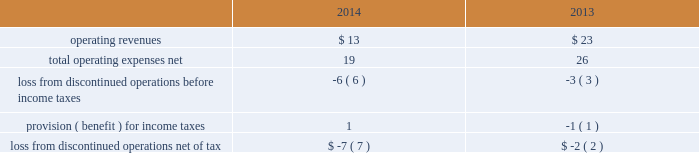During 2014 , the company closed on thirteen acquisitions of various regulated water and wastewater systems for a total aggregate purchase price of $ 9 .
Assets acquired , principally plant , totaled $ 17 .
Liabilities assumed totaled $ 8 , including $ 5 of contributions in aid of construction and assumed debt of $ 2 .
During 2013 , the company closed on fifteen acquisitions of various regulated water and wastewater systems for a total aggregate net purchase price of $ 24 .
Assets acquired , primarily utility plant , totaled $ 67 .
Liabilities assumed totaled $ 43 , including $ 26 of contributions in aid of construction and assumed debt of $ 13 .
Included in these totals was the company 2019s november 14 , 2013 acquisition of all of the capital stock of dale service corporation ( 201cdale 201d ) , a regulated wastewater utility company , for a total cash purchase price of $ 5 ( net of cash acquired of $ 7 ) , plus assumed liabilities .
The dale acquisition was accounted for as a business combination ; accordingly , operating results from november 14 , 2013 were included in the company 2019s results of operations .
The purchase price was allocated to the net tangible and intangible assets based upon their estimated fair values at the date of acquisition .
The company 2019s regulatory practice was followed whereby property , plant and equipment ( rate base ) was considered fair value for business combination purposes .
Similarly , regulatory assets and liabilities acquired were recorded at book value and are subject to regulatory approval where applicable .
The acquired debt was valued in a manner consistent with the company 2019s level 3 debt .
See note 17 2014fair value of financial instruments .
Non-cash assets acquired in the dale acquisition , primarily utility plant , totaled $ 41 ; liabilities assumed totaled $ 36 , including debt assumed of $ 13 and contributions of $ 19 .
Divestitures in november 2014 , the company completed the sale of terratec , previously included in the market-based businesses .
After post-close adjustments , net proceeds from the sale totaled $ 1 , and the company recorded a pretax loss on sale of $ 1 .
The table summarizes the operating results of discontinued operations presented in the accompanying consolidated statements of operations for the years ended december 31: .
The provision for income taxes of discontinued operations includes the recognition of tax expense related to the difference between the tax basis and book basis of assets upon the sales of terratec that resulted in taxable gains , since an election was made under section 338 ( h ) ( 10 ) of the internal revenue code to treat the sales as asset sales .
There were no assets or liabilities of discontinued operations in the accompanying consolidated balance sheets as of december 31 , 2015 and 2014. .
What was the percentage growth in operating expenses from 2013 to 2014? 
Rationale: the percent growth from year to year is the change from year to year divided by the base year
Computations: ((19 - 26) / 26)
Answer: -0.26923. 